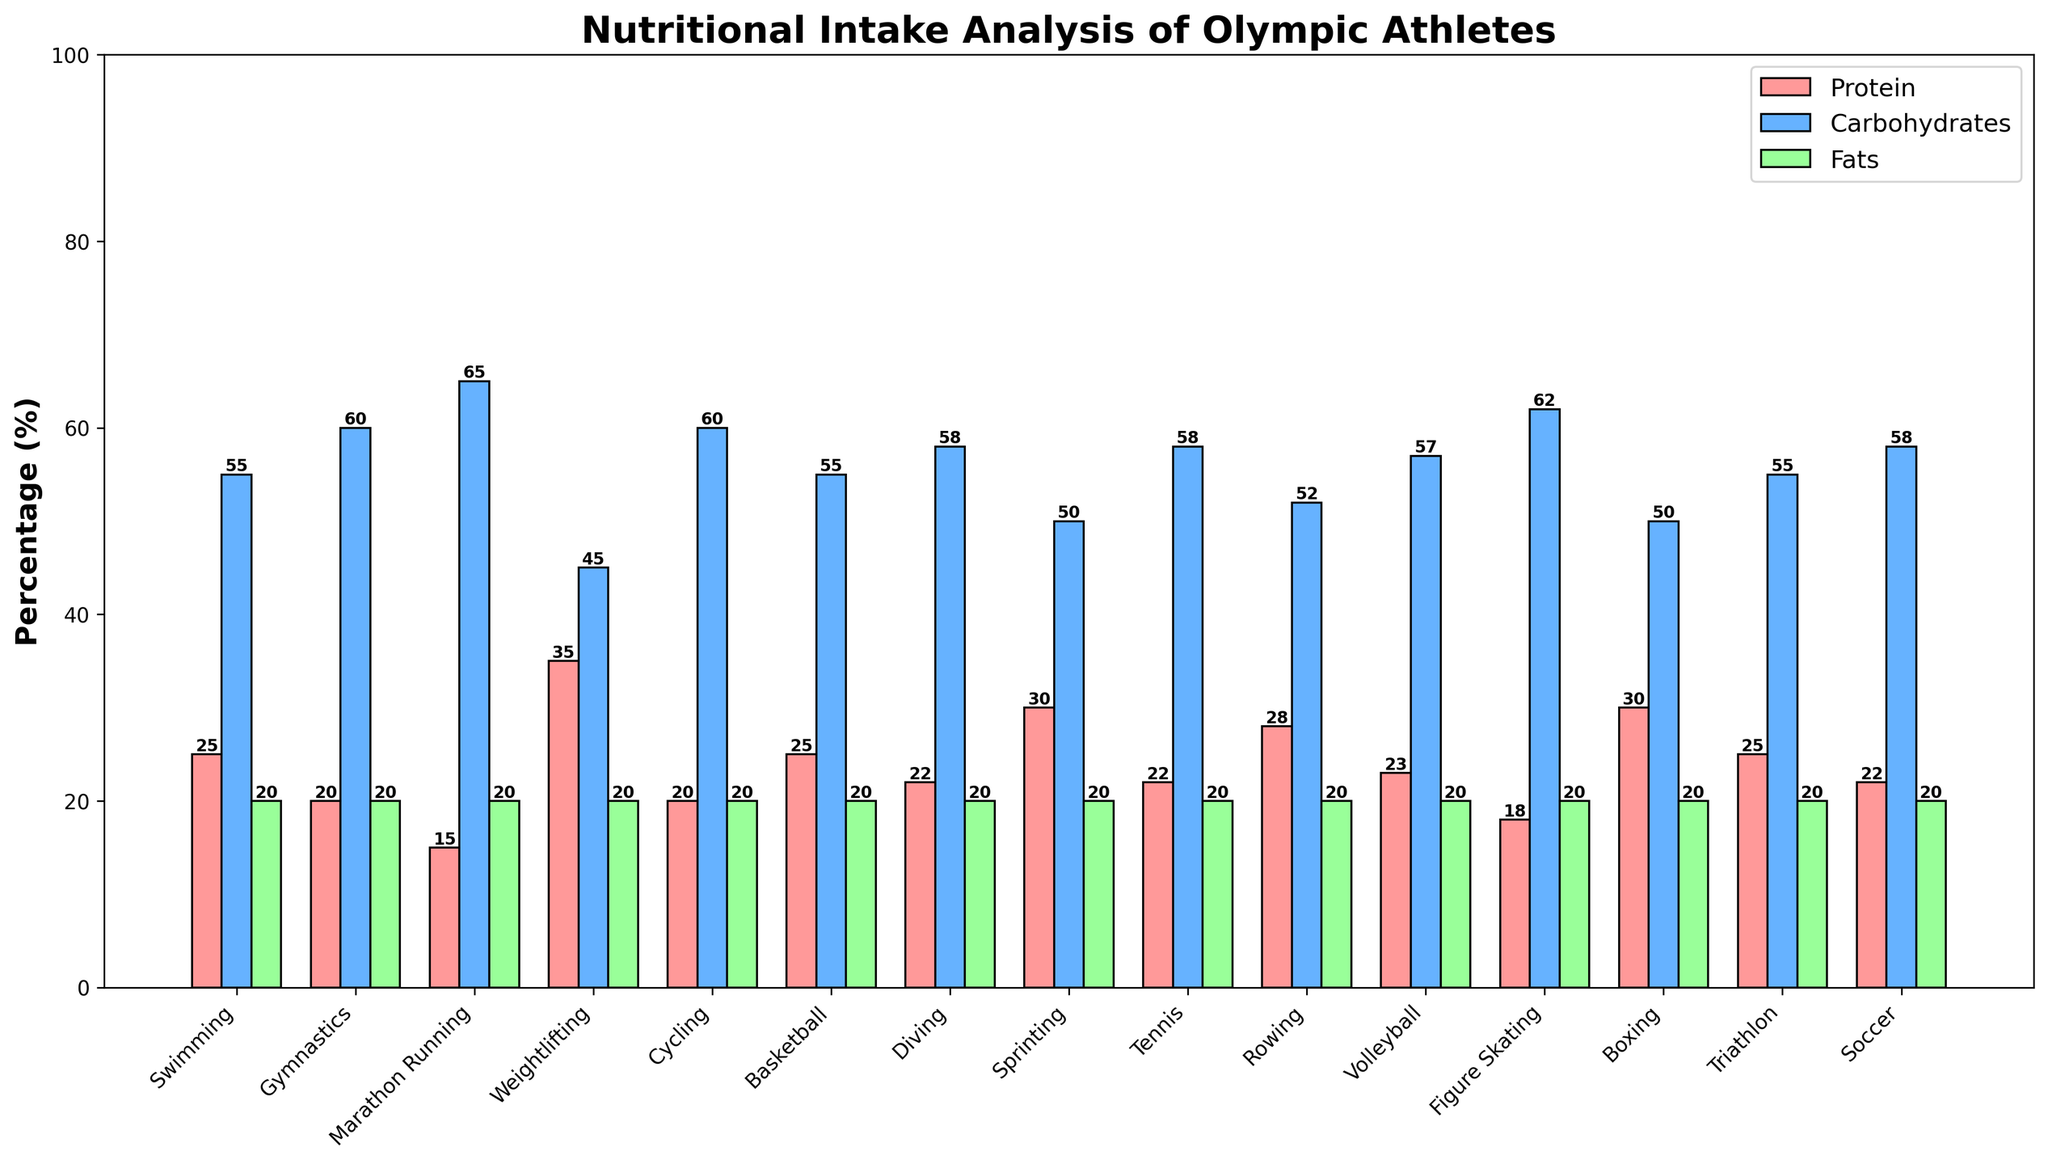What percentage of nutritional intake comprises carbohydrates for Marathon Running? Marathon Running has a bar labeled 'Carbohydrates' with a height indicating its value as 65%.
Answer: 65 Which sport has the highest protein intake percentage? By looking at all bars labeled 'Protein,' Weightlifting has the tallest bar with protein at 35%. Other sports have lower or equal protein intake values.
Answer: Weightlifting Which two sports have an equal percentage of carbohydrate intake? Comparing the carbohydrate bars, both Gymnastics and Cycling show 60% intake, making their carbohydrate percentage equal.
Answer: Gymnastics and Cycling What is the combined percentage of protein and fat intake for Sprinting? For Sprinting, the protein intake bar is at 30% and the fats intake bar is at 20%. Adding these together: 30 + 20 = 50%.
Answer: 50 Among Swimming, Gymnastics, and Figure Skating, which sport has the lowest percentage of protein intake? Comparing the protein intake for Swimming (25%), Gymnastics (20%), and Figure Skating (18%), Figure Skating has the lowest percentage.
Answer: Figure Skating What is the average carbohydrate intake percentage across the three sports with the highest protein intake? The three sports with the highest protein intake are Weightlifting (35%), Sprinting (30%), and Boxing (30%). Their carbohydrate percentages are 45%, 50%, and 50%, respectively. The average is calculated as (45 + 50 + 50) / 3 = 48.33%.
Answer: 48.33 How does the protein intake for Tennis compare to that for Volleyball? For Tennis, the protein intake is 22%, and for Volleyball, it is 23%. Volleyball has a slightly higher protein intake than Tennis.
Answer: Volleyball has a higher intake What is the total percentage of fat intake for all sports combined? All sports have a fat intake percentage of 20%. There are 15 sports in total, so the combined percentage is 20 * 15 = 300%.
Answer: 300 